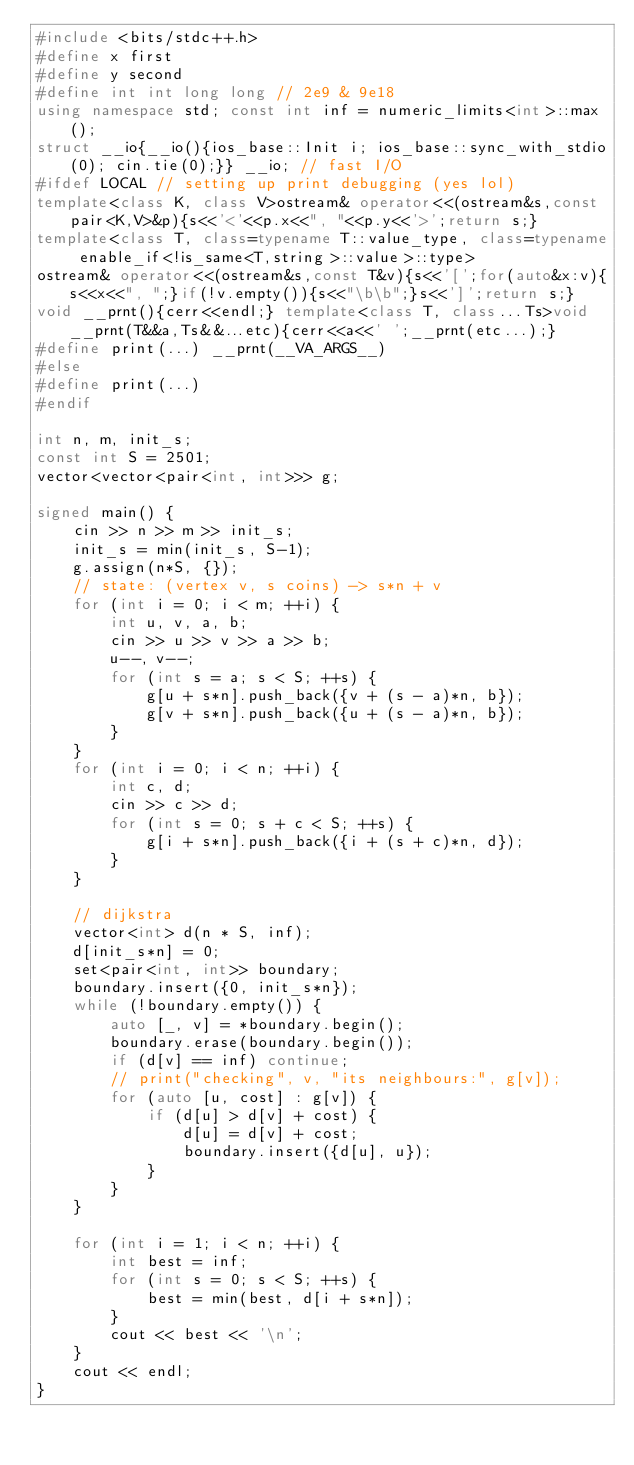Convert code to text. <code><loc_0><loc_0><loc_500><loc_500><_C++_>#include <bits/stdc++.h>
#define x first
#define y second
#define int int long long // 2e9 & 9e18
using namespace std; const int inf = numeric_limits<int>::max();
struct __io{__io(){ios_base::Init i; ios_base::sync_with_stdio(0); cin.tie(0);}} __io; // fast I/O
#ifdef LOCAL // setting up print debugging (yes lol)
template<class K, class V>ostream& operator<<(ostream&s,const pair<K,V>&p){s<<'<'<<p.x<<", "<<p.y<<'>';return s;}
template<class T, class=typename T::value_type, class=typename enable_if<!is_same<T,string>::value>::type>
ostream& operator<<(ostream&s,const T&v){s<<'[';for(auto&x:v){s<<x<<", ";}if(!v.empty()){s<<"\b\b";}s<<']';return s;}
void __prnt(){cerr<<endl;} template<class T, class...Ts>void __prnt(T&&a,Ts&&...etc){cerr<<a<<' ';__prnt(etc...);}
#define print(...) __prnt(__VA_ARGS__)
#else
#define print(...)
#endif

int n, m, init_s;
const int S = 2501;
vector<vector<pair<int, int>>> g;

signed main() {
    cin >> n >> m >> init_s;
    init_s = min(init_s, S-1);
    g.assign(n*S, {});
    // state: (vertex v, s coins) -> s*n + v
    for (int i = 0; i < m; ++i) {
        int u, v, a, b;
        cin >> u >> v >> a >> b;
        u--, v--;
        for (int s = a; s < S; ++s) {
            g[u + s*n].push_back({v + (s - a)*n, b});
            g[v + s*n].push_back({u + (s - a)*n, b});
        }
    }
    for (int i = 0; i < n; ++i) {
        int c, d;
        cin >> c >> d;
        for (int s = 0; s + c < S; ++s) {
            g[i + s*n].push_back({i + (s + c)*n, d});
        }
    }

    // dijkstra
    vector<int> d(n * S, inf);
    d[init_s*n] = 0;
    set<pair<int, int>> boundary;
    boundary.insert({0, init_s*n});
    while (!boundary.empty()) {
        auto [_, v] = *boundary.begin();
        boundary.erase(boundary.begin());
        if (d[v] == inf) continue;
        // print("checking", v, "its neighbours:", g[v]);
        for (auto [u, cost] : g[v]) {
            if (d[u] > d[v] + cost) {
                d[u] = d[v] + cost;
                boundary.insert({d[u], u});
            }
        }
    }

    for (int i = 1; i < n; ++i) {
        int best = inf;
        for (int s = 0; s < S; ++s) {
            best = min(best, d[i + s*n]);
        }
        cout << best << '\n';
    }
    cout << endl;
}
</code> 